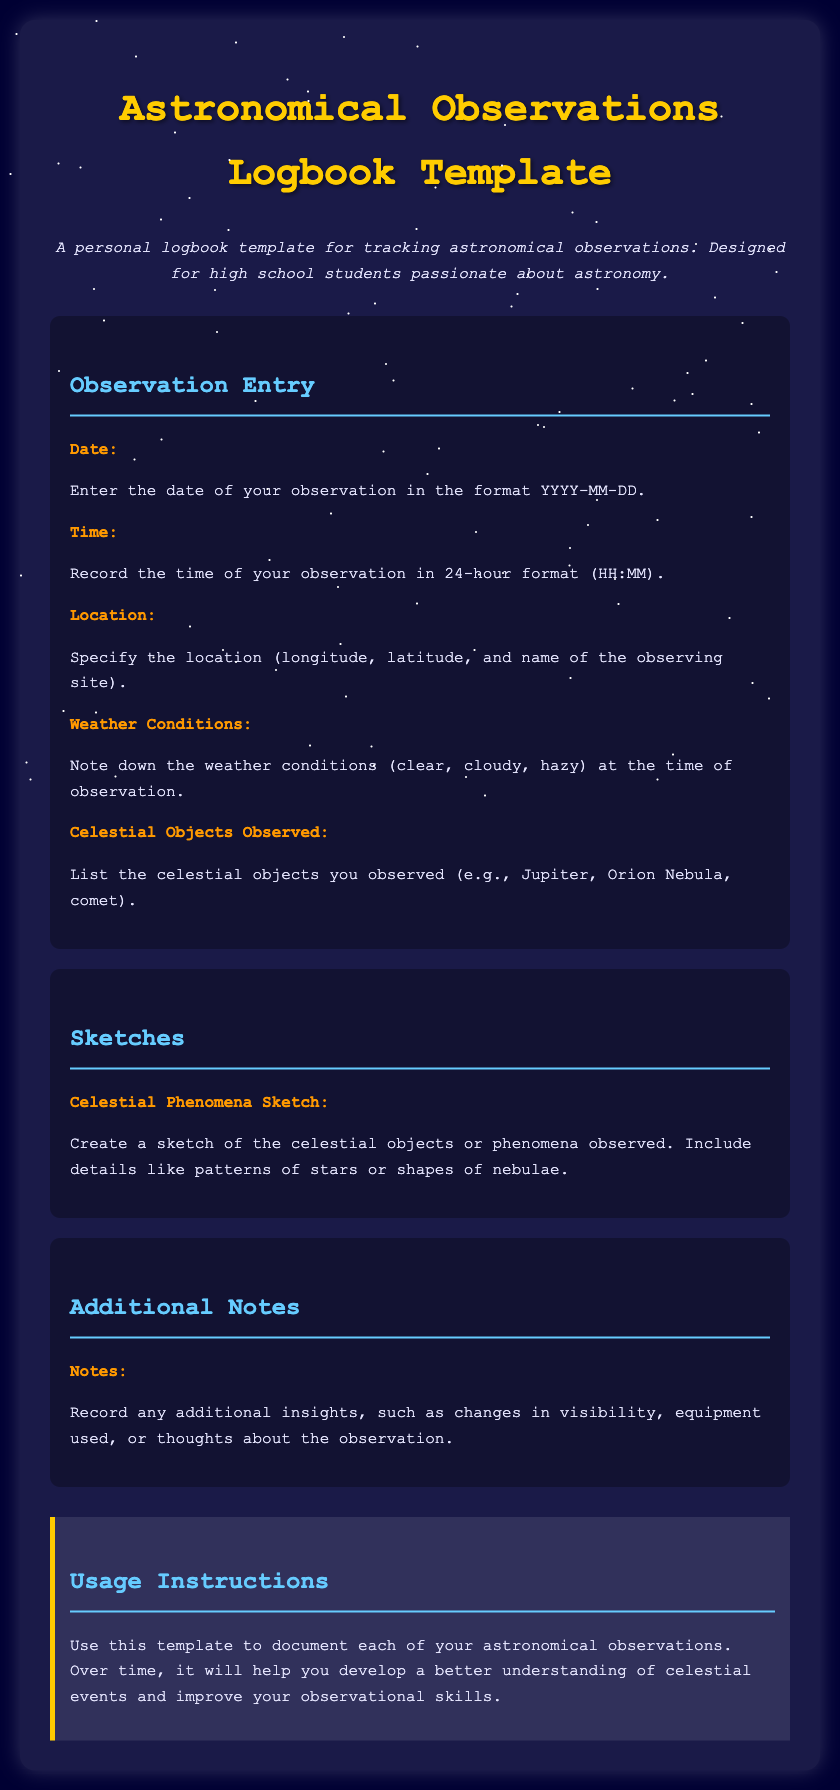What is the title of the document? The title is presented at the top of the page in a large font, indicating the purpose and content of the document.
Answer: Astronomical Observations Logbook Template What should you enter for the "Date" field? The instructions specify how the date should be formatted for the logbook entry, ensuring consistency in documenting observations.
Answer: YYYY-MM-DD What color is the header text? The header text color is important as it helps distinguish different sections of the document visually.
Answer: #ffcc00 What section contains information about sketching celestial phenomena? Identifying the sections helps users locate specific types of entries quickly.
Answer: Sketches What are the weather conditions that should be noted? This information is crucial for understanding the observational context of each entry in the logbook.
Answer: Clear, cloudy, hazy What is the purpose of the logbook template? This gives insight into the overall goal of the document and how it can assist users.
Answer: Tracking astronomical observations How many observations can be documented using this template? This question assesses the scalability of the logbook based on the provided structure.
Answer: Unlimited What should you record in the "Additional Notes" section? This highlights the specific types of insights that users can include, which may enhance their observational skills.
Answer: Additional insights What is the recommended format for the "Time" entry? This helps ensure that all users follow a standard practice when logging times.
Answer: 24-hour format (HH:MM) 